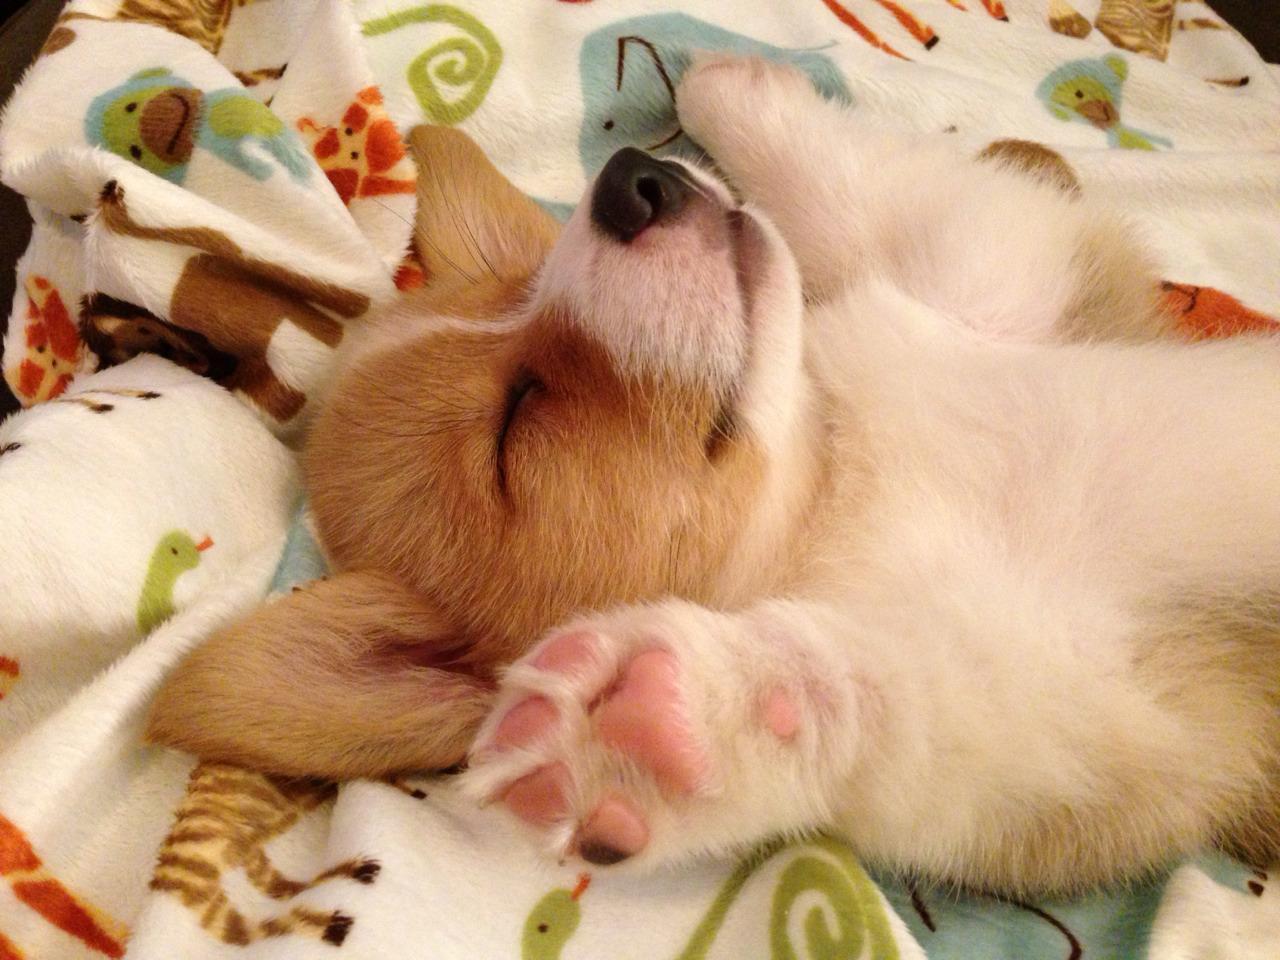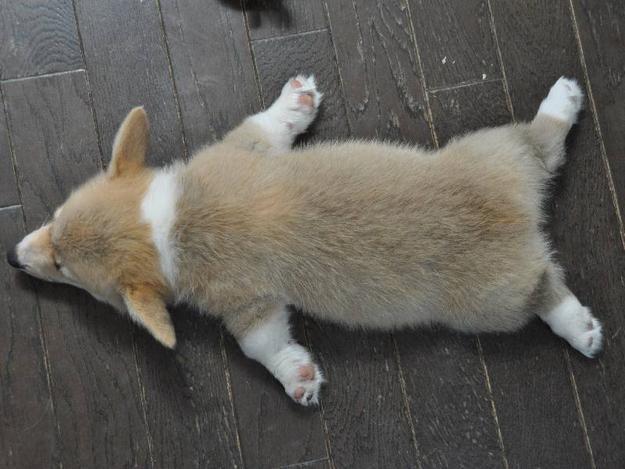The first image is the image on the left, the second image is the image on the right. For the images shown, is this caption "There is at least one dog lying on its front or back." true? Answer yes or no. Yes. The first image is the image on the left, the second image is the image on the right. Considering the images on both sides, is "There is at most 1 young Corgi laying on it right side, sleeping." valid? Answer yes or no. No. 